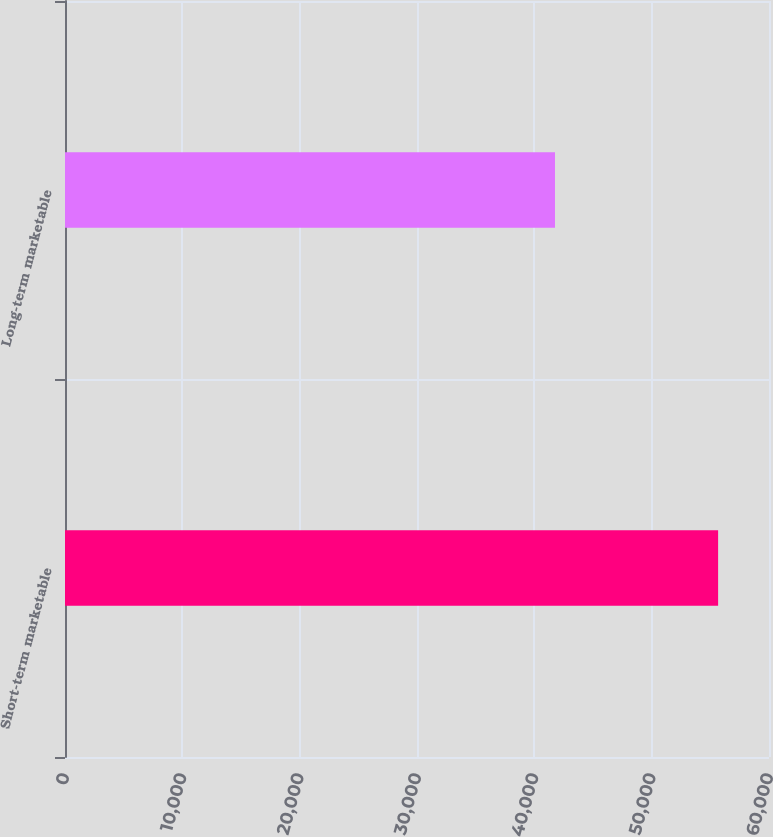Convert chart to OTSL. <chart><loc_0><loc_0><loc_500><loc_500><bar_chart><fcel>Short-term marketable<fcel>Long-term marketable<nl><fcel>55663<fcel>41761<nl></chart> 